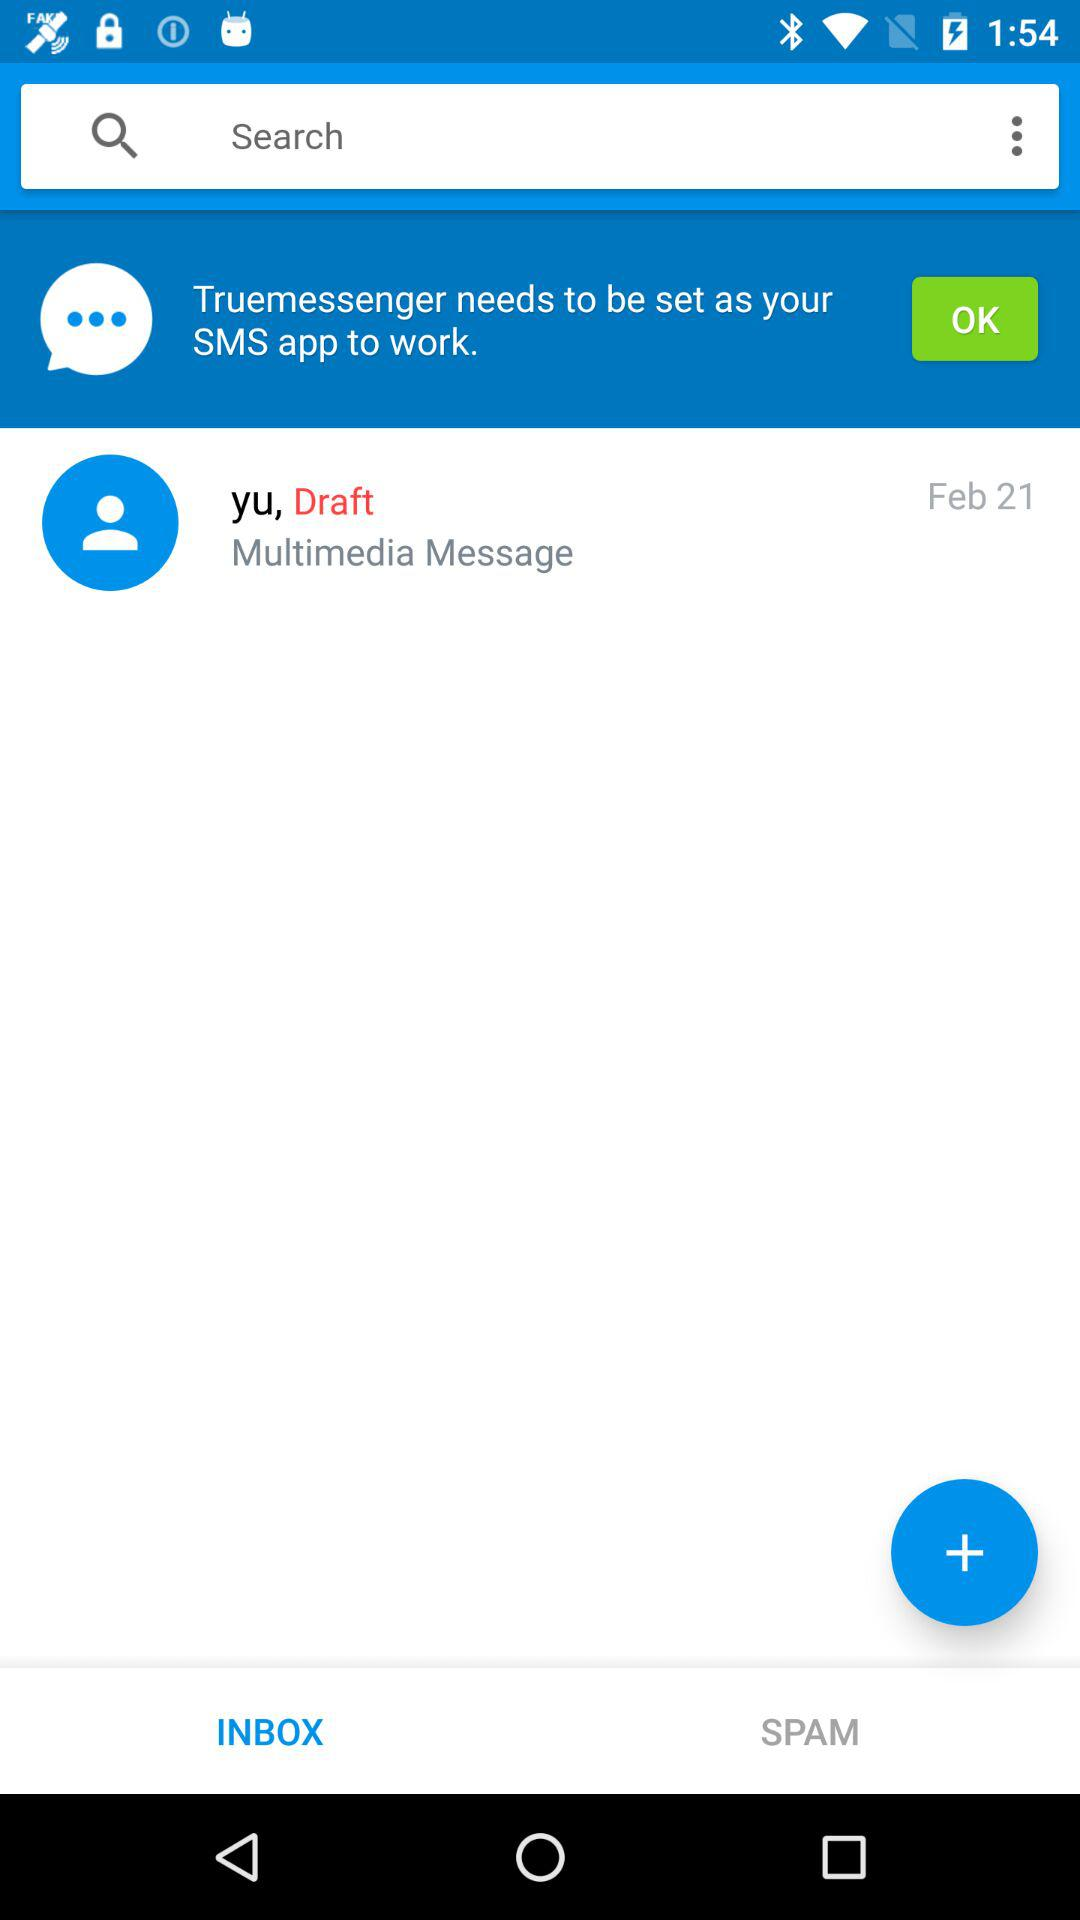What is the type of drafted message? The type of drafted message is "Multimedia Message". 